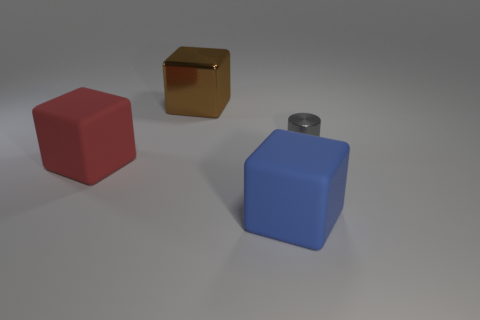What number of other blue matte things are the same size as the blue thing?
Offer a terse response. 0. There is a metal object on the right side of the blue thing; are there any tiny cylinders in front of it?
Offer a very short reply. No. How many things are red rubber cubes or blue rubber things?
Offer a terse response. 2. The large cube that is in front of the large matte block on the left side of the big matte object right of the large red block is what color?
Provide a succinct answer. Blue. Is there any other thing that has the same color as the cylinder?
Ensure brevity in your answer.  No. Do the brown metal thing and the cylinder have the same size?
Your answer should be very brief. No. What number of things are either objects to the left of the big metal cube or matte things that are on the right side of the brown metal block?
Your answer should be very brief. 2. The big blue object that is left of the thing that is on the right side of the big blue block is made of what material?
Provide a succinct answer. Rubber. Do the big blue rubber thing and the small thing have the same shape?
Give a very brief answer. No. There is a cube on the right side of the brown shiny thing; what size is it?
Provide a short and direct response. Large. 